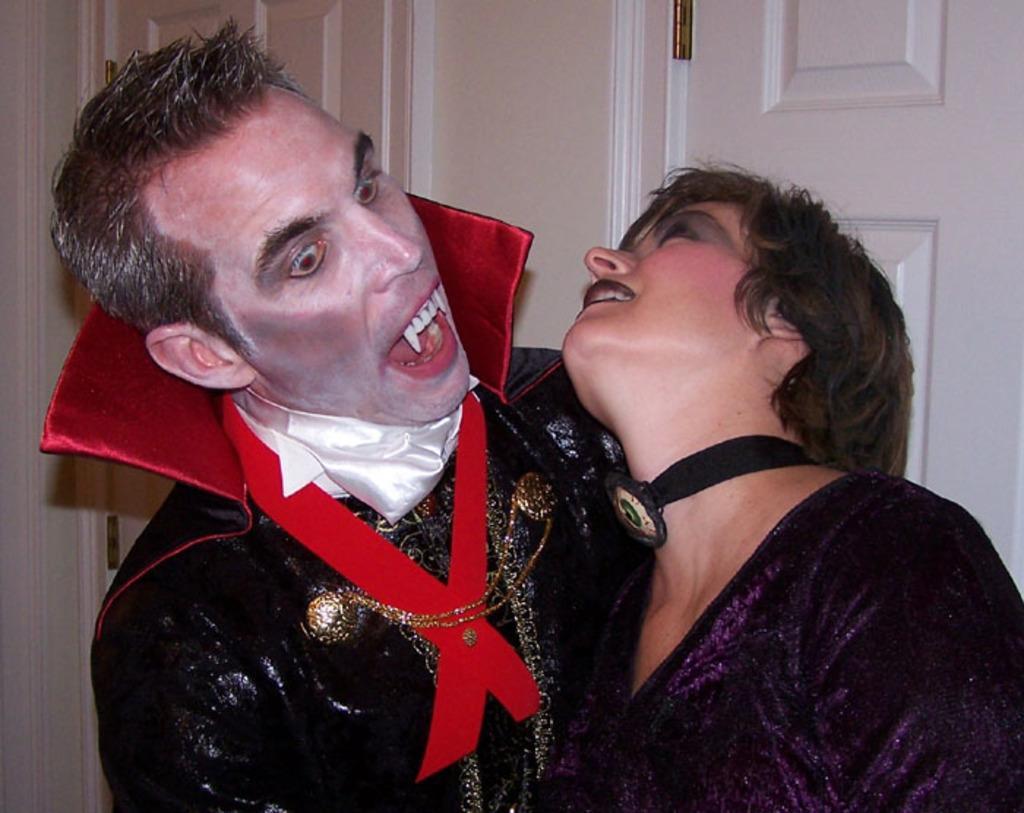Describe this image in one or two sentences. In this image there are people with costumes in the foreground. There are doors and there is a wall in the background. 